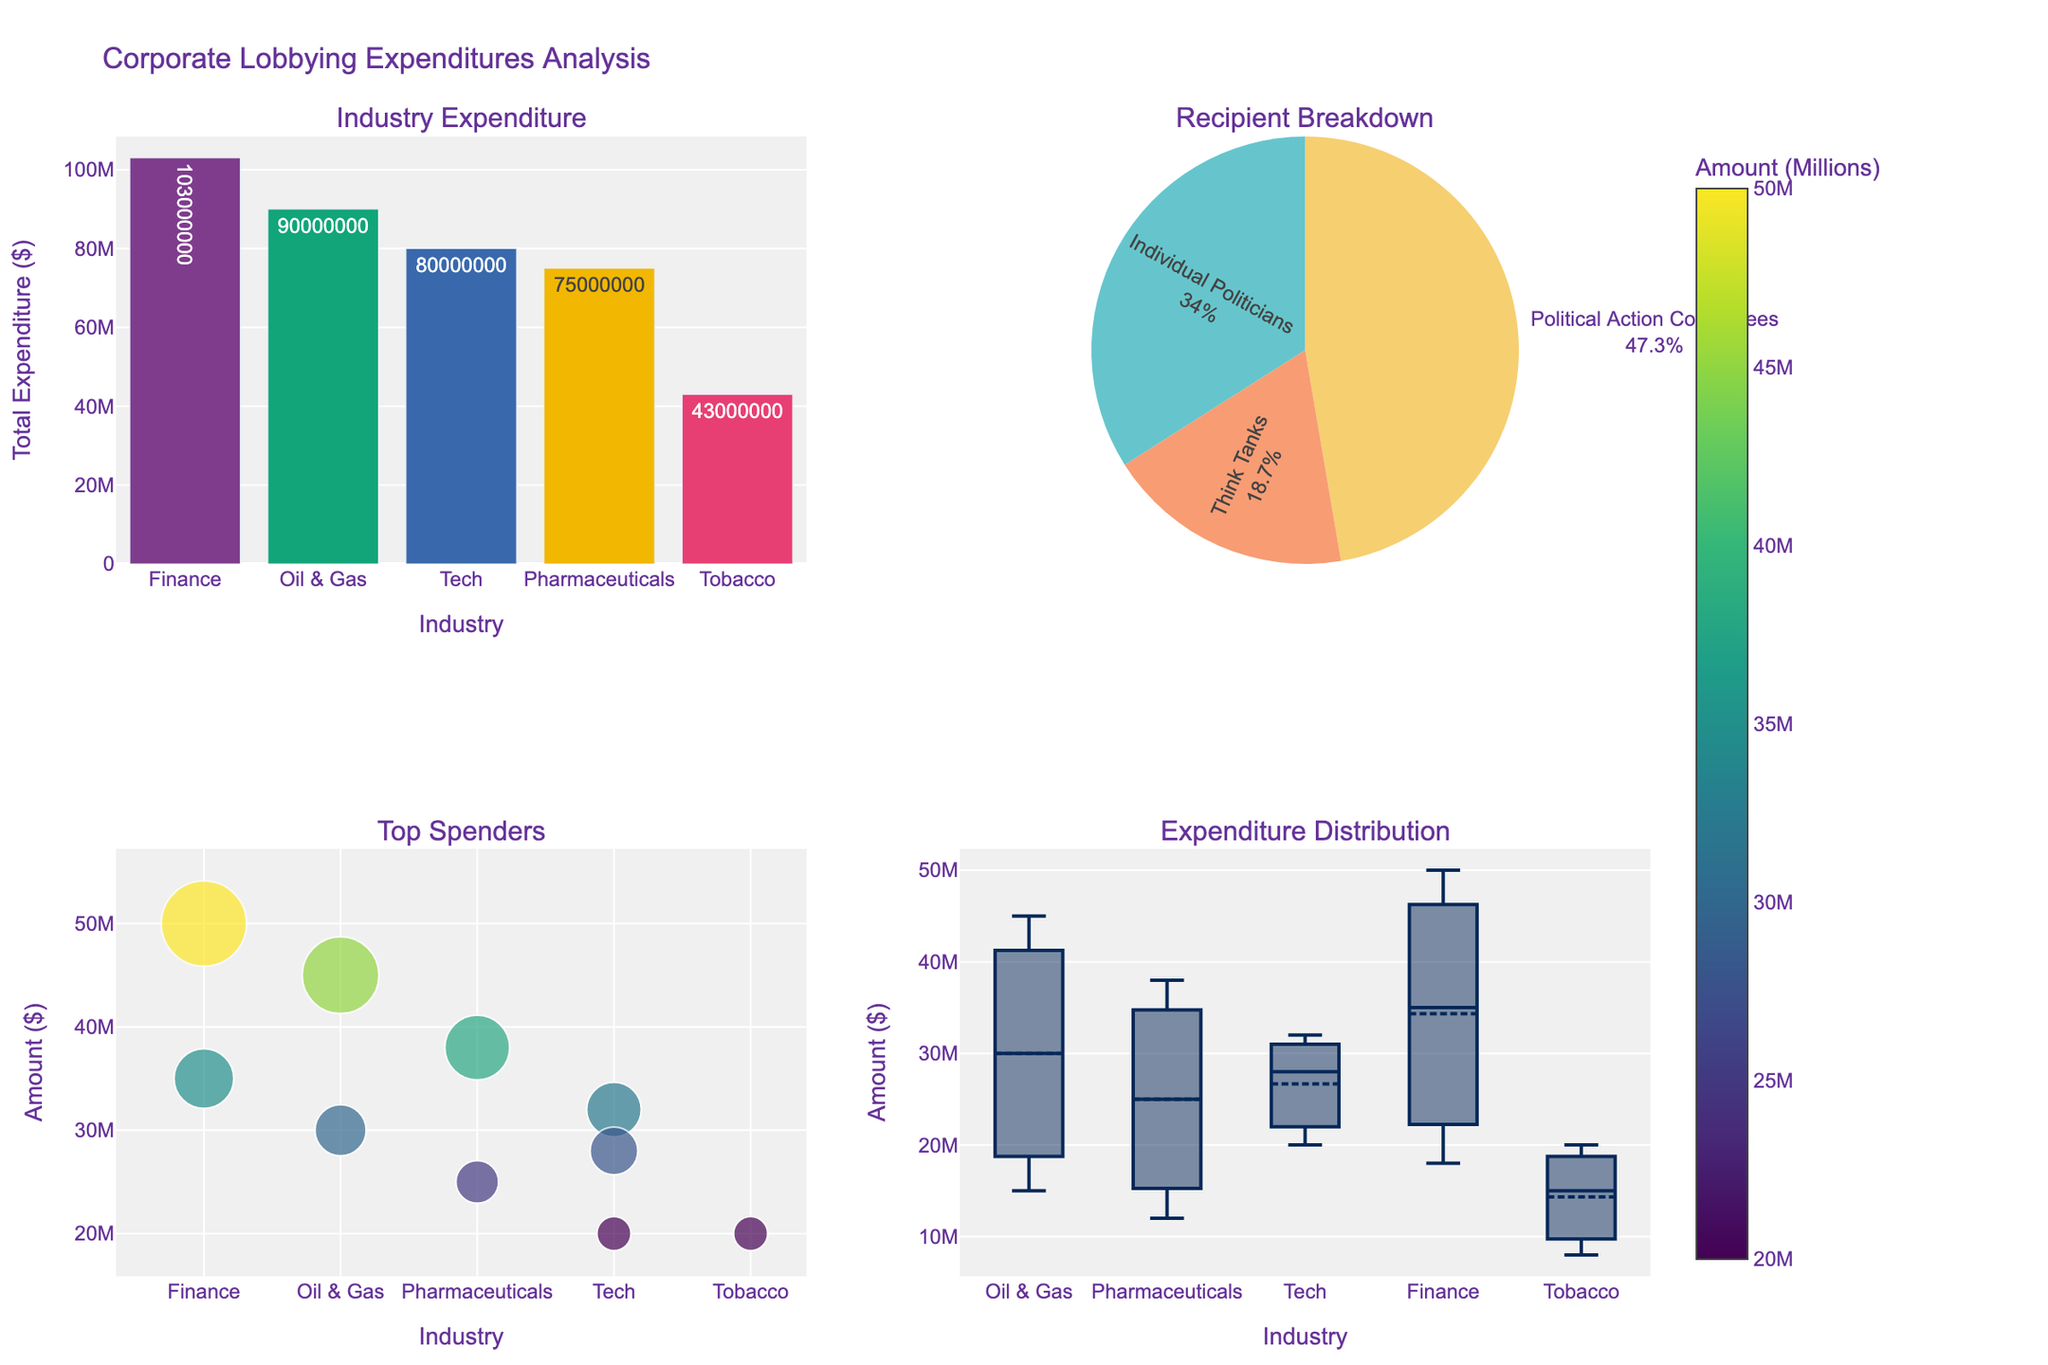What's the title of the figure? The title is usually placed at the top of the figure and gives an overview of what the figure represents.
Answer: "Corporate Lobbying Expenditures Analysis" How many types of charts are used in the figure? There are four subplots, each with a different chart type, indicated by the visual representation: bar chart, pie chart, scatter plot, and box plot.
Answer: 4 Which industry has the highest total lobbying expenditure? Look at the bar chart in the top-left corner with total expenditures by industry. The bar with the highest value represents the industry with the highest expenditure.
Answer: Finance In the pie chart, which recipient category receives the smallest portion of the expenditures? The pie chart breaks down the expenditures by recipient categories. The smallest portion is indicated by the smallest slice.
Answer: Think Tanks What's the difference in expenditure between the highest and lowest spending industries? According to the bar chart, determine the expenditure of the highest and lowest spending industries, then subtract the lowest from the highest. Finance: 103M, Tobacco: 43M. 103M - 43M = 60M.
Answer: 60M Which recipient category does the majority of lobbying expenditure go towards? The pie chart visually shows the size of the slices representing each category, with the largest slice reflecting the majority expenditure.
Answer: Political Action Committees How is the expenditure distributed within the Tech industry according to the box plot? Look at the box plot specifically for the Tech industry. The distribution is indicated by the spread of the data points, mean, and outliers if any.
Answer: The data is spread with some variance Which individual industry spending falls outside the normal range in the box plot? Outliers in a box plot are usually marked separately; observe which industry's expenditures are marked as outliers.
Answer: None In the scatter plot for top spenders, which industry's recipient received the highest amount? Find the recipient with the largest size marker in the scatter plot, identified by its axis positions and text label.
Answer: Finance's Political Action Committees Which recipient category has the second-largest total expenditure according to the pie chart? Identify the second-largest slice in the pie chart, which represents the second-largest expenditure.
Answer: Individual Politicians 